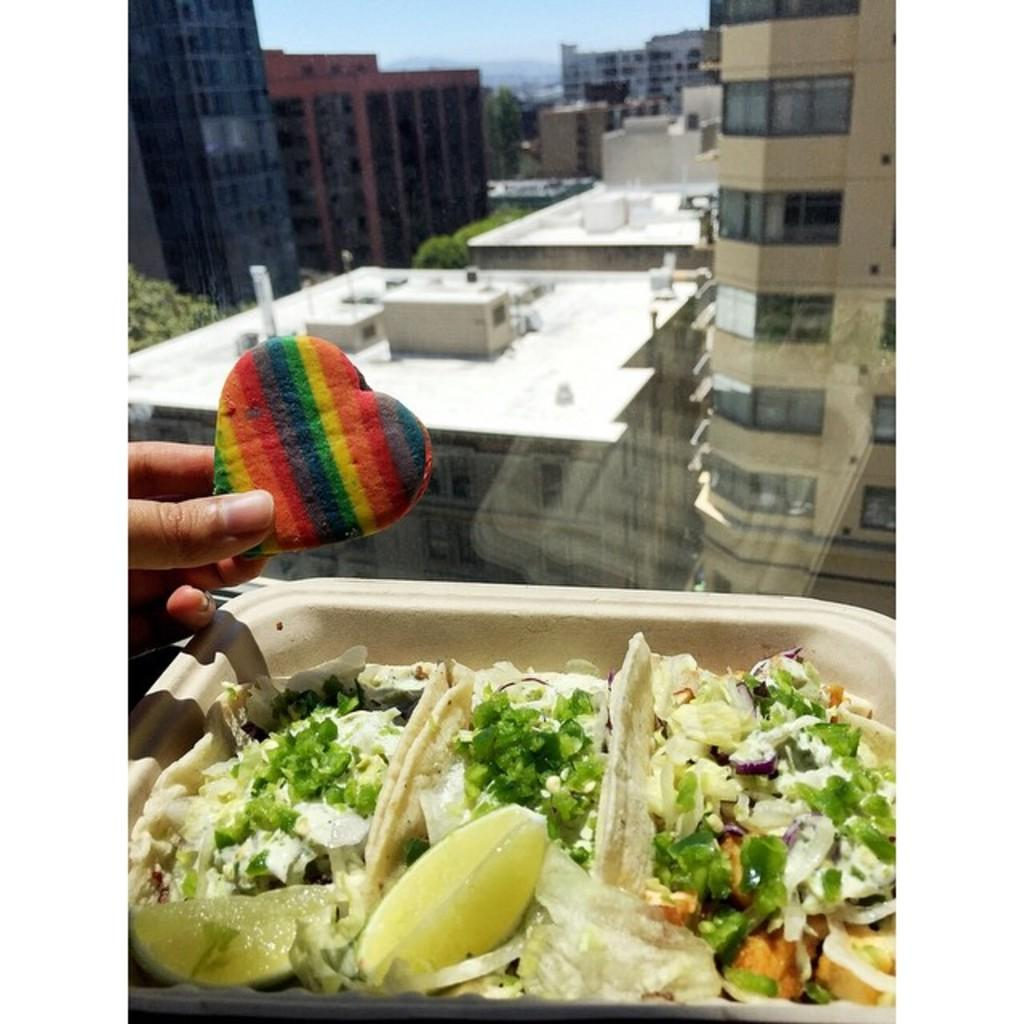What is the person's hand holding in the image? There is a person's hand holding a biscuit in the image. What else can be seen on the plate in the image? There is a food item on a plate in the image. What can be seen in the background of the image? There are buildings and trees in the background of the image. What type of fear is the person experiencing while holding the biscuit in the image? There is no indication of fear in the image; the person is simply holding a biscuit. Can you see the person's father in the image? There is no mention of a father or any other person in the image, only a person's hand holding a biscuit. 